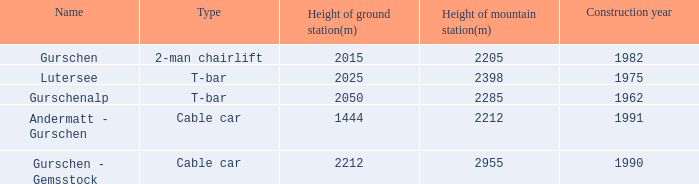How much Height of ground station(m) has a Name of lutersee, and a Height of mountain station(m) larger than 2398? 0.0. 